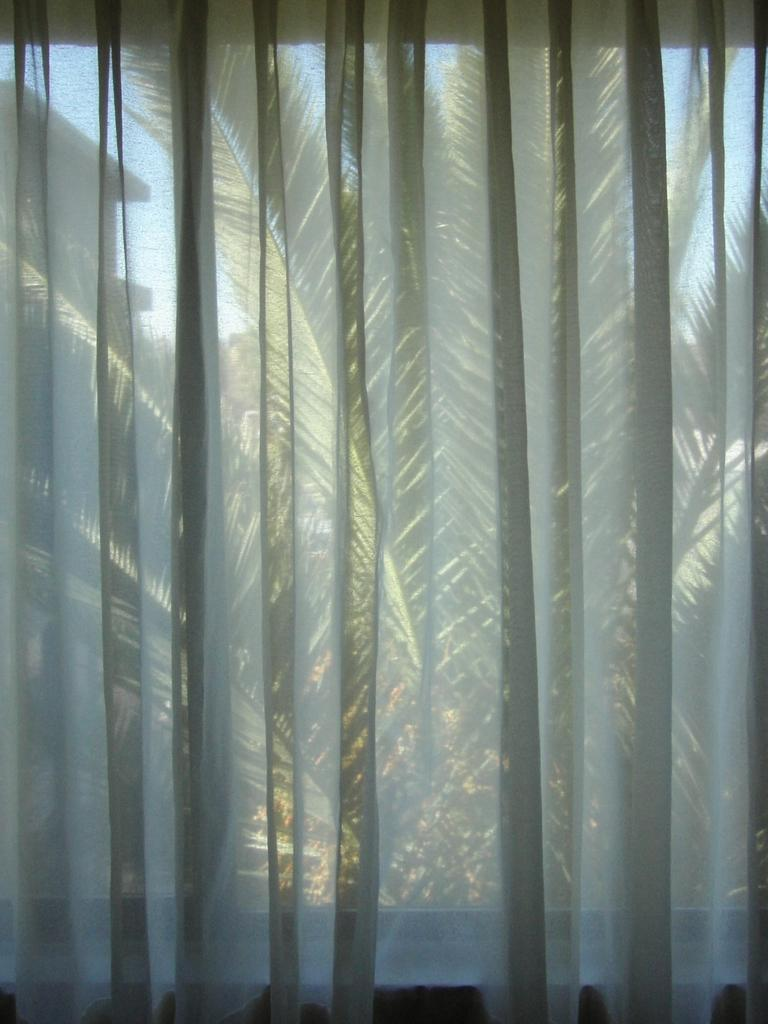What type of window treatment is visible in the image? There are white curtains in the image. What can be seen in the background of the image? There is a tree in the background of the image. What type of bun is being used to hold the curtains in the image? There is no bun present in the image; the curtains are not held up by any bun. What account can be seen in the image? There is no account visible in the image, as it is a photograph and not a digital platform. 